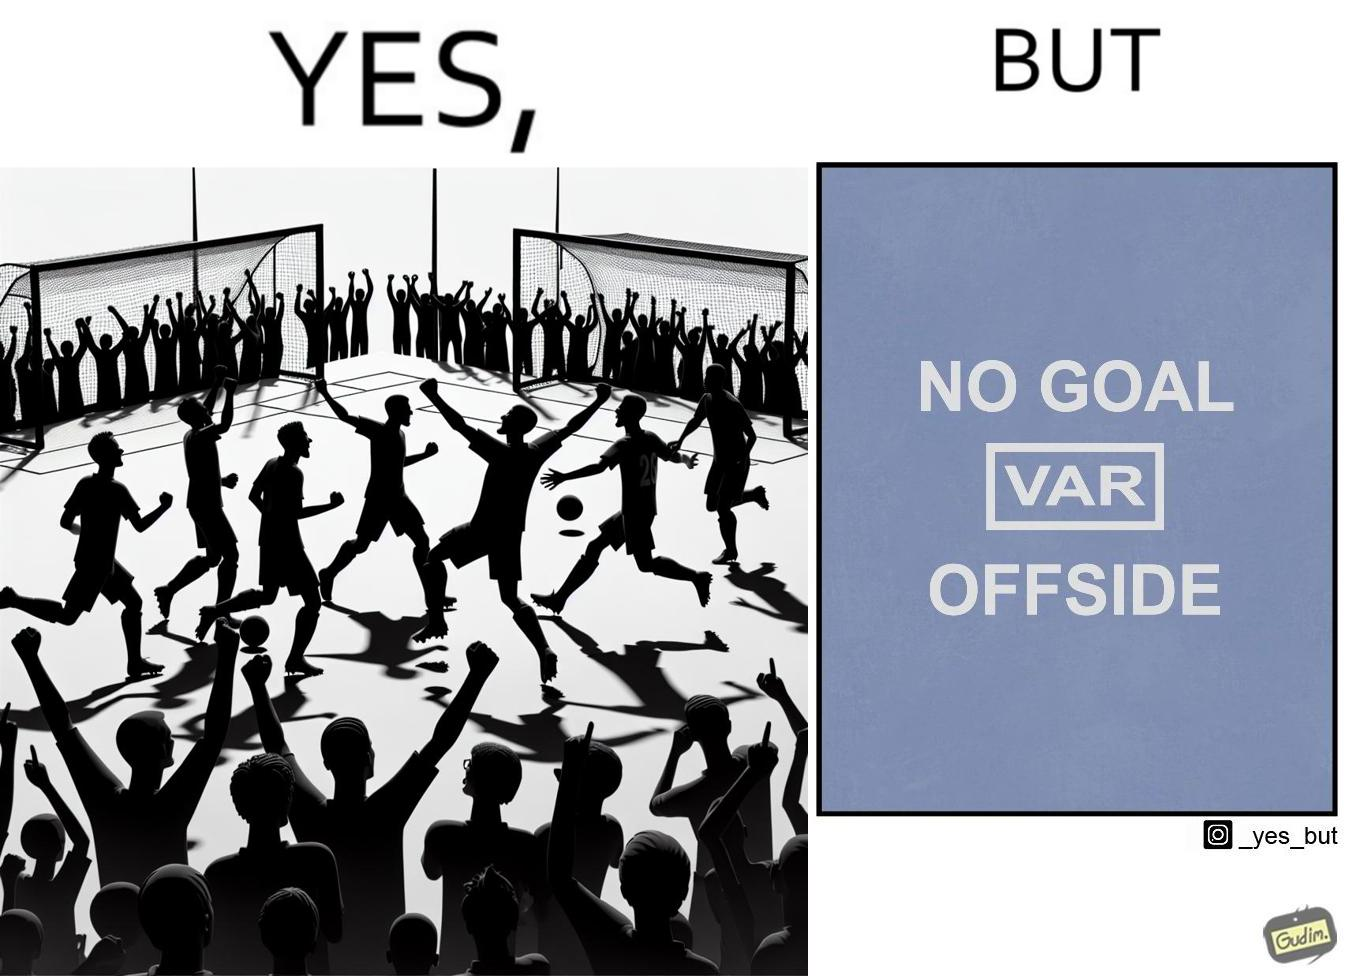Provide a description of this image. The image is ironical, as the team is celebrating as they think that they have scored a goal, but the sign on the screen says that it is an offside, and not a goal. This is a very common scenario in football matches. 